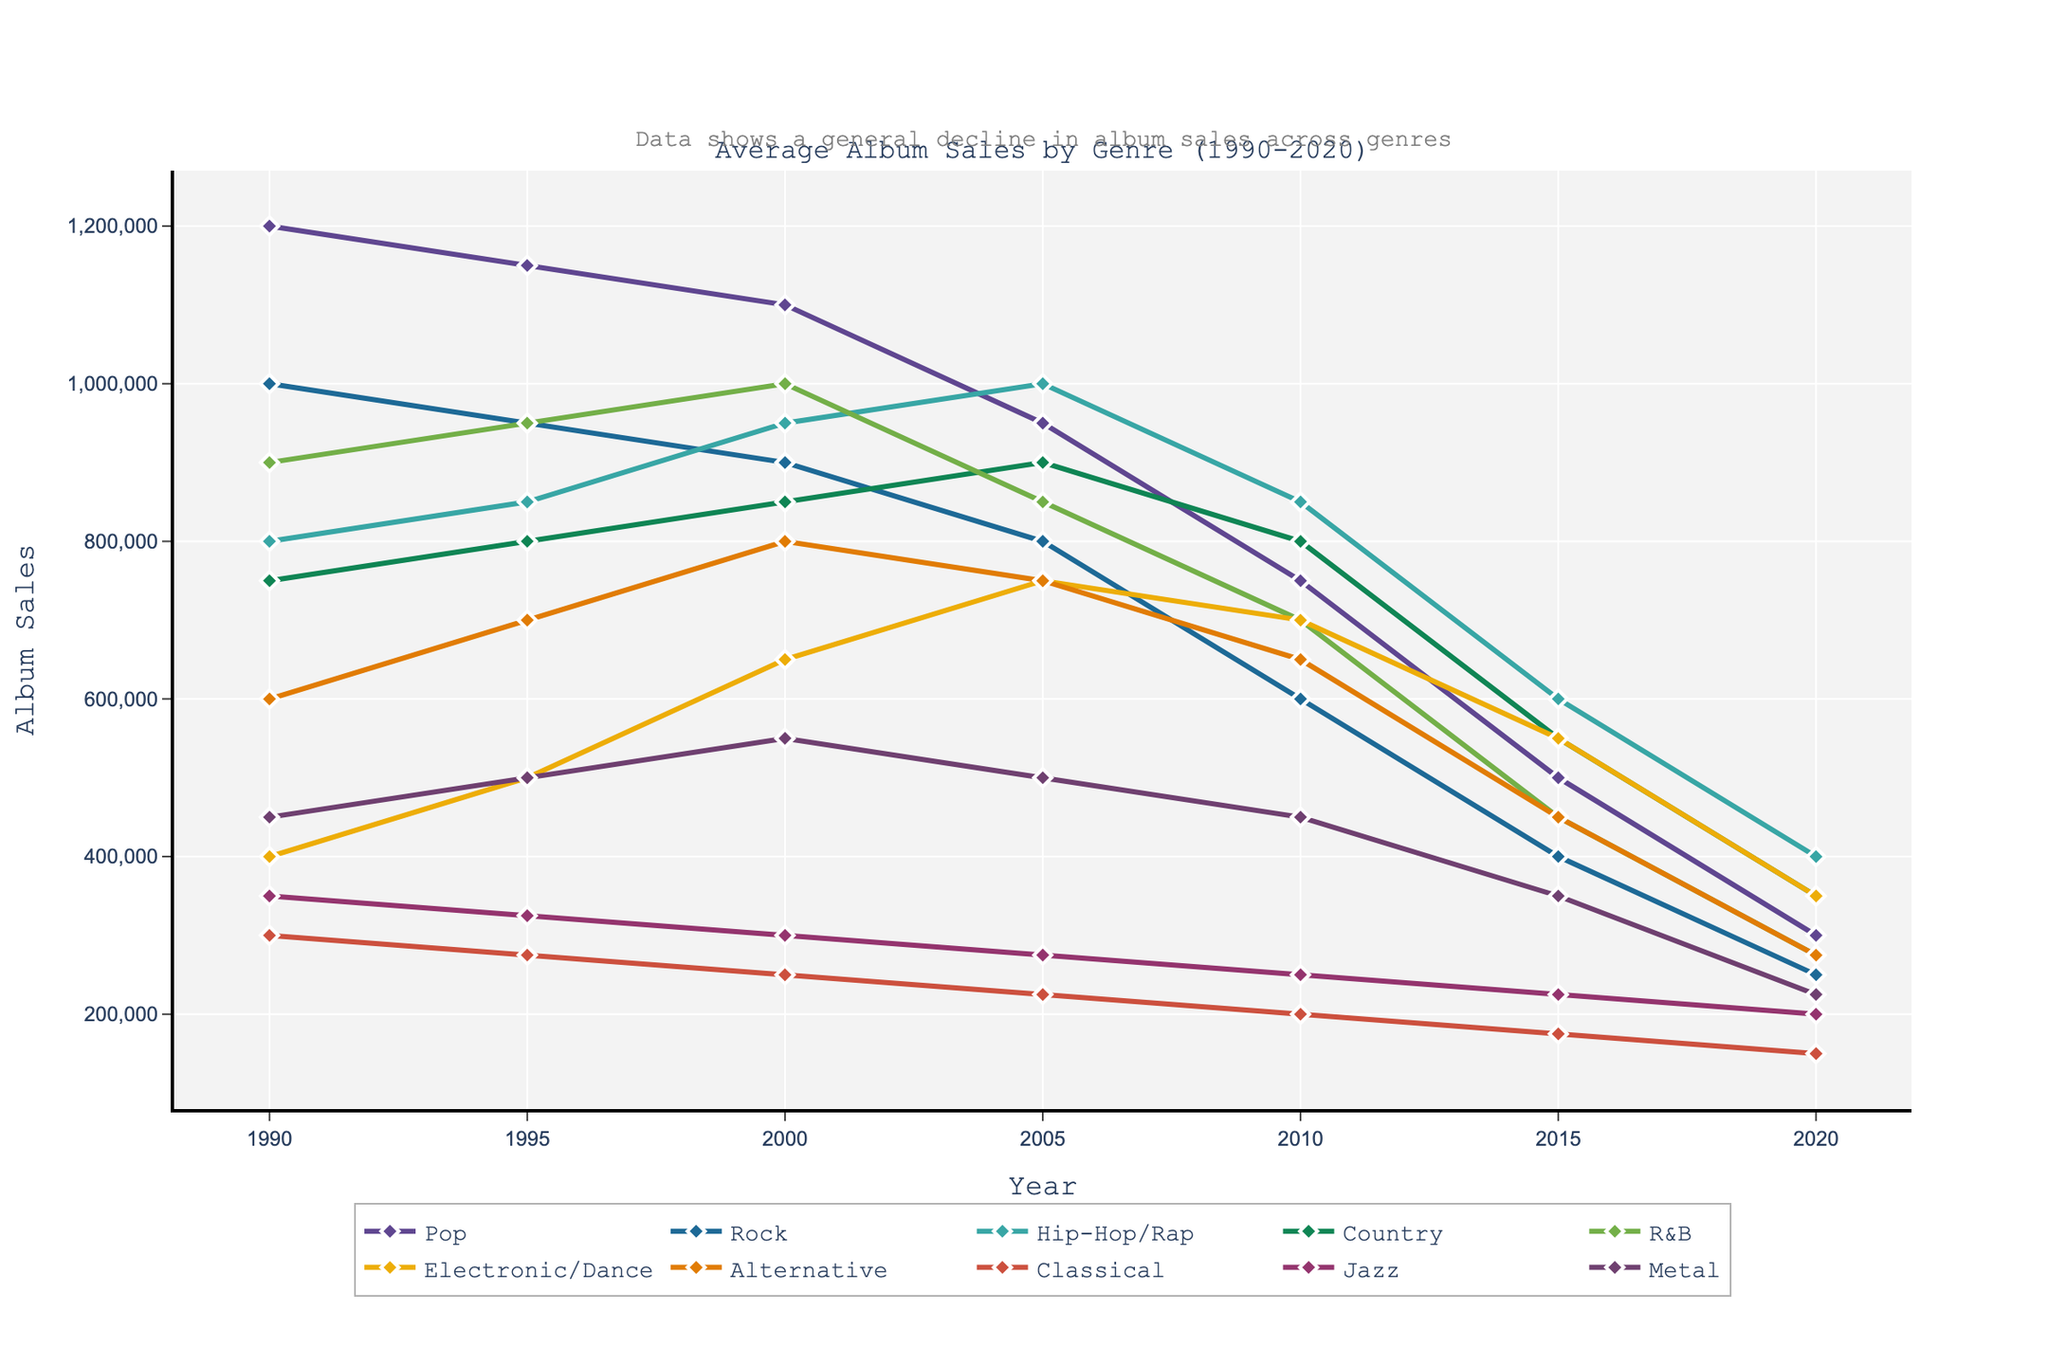What's the overall trend in album sales for most genres from 1990 to 2020? Most genres show a declining trend in album sales from 1990 to 2020. By examining the slopes of the lines for each genre, it is apparent that the lines generally slope downward over time.
Answer: Declining Which genre had the highest average album sales in 2000? By referring to the height of the lines at the year 2000 marker, the R&B genre had the highest average album sales in 2000 with 1,000,000 units sold.
Answer: R&B Which genres maintained their album sales relatively stable from 1990 to 2000? By comparing the slopes of the lines between 1990 to 2000, Electronic/Dance and Jazz show relatively stable sales where their lines do not have large dips or rises.
Answer: Electronic/Dance, Jazz Which genre had the steepest decline in album sales from 1990 to 2020? To determine the steepest decline, compare the difference between the starting and ending points of each line. Pop had the steepest decline, going from 1,200,000 units in 1990 to 300,000 units in 2020.
Answer: Pop How do the sales of Hip-Hop/Rap in 2010 compare to the sales of Rock in 2000? By looking at the Y-axis values at the respective years, Hip-Hop/Rap in 2010 had approximately 850,000 units sold, while Rock in 2000 had about 900,000 units sold.
Answer: Rock had higher sales in 2000 What’s the average album sales for the Pop genre between 1990 and 2020? Sum of sales values for Pop (1200000, 1150000, 1100000, 950000, 750000, 500000, 300000) and divide by 7. The calculation is (1200000 + 1150000 + 1100000 + 950000 + 750000 + 500000 + 300000) / 7
Answer: 785714 Which genre saw an increase in album sales between 1990 and 2005? By analyzing the lines from 1990 to 2005, Hip-Hop/Rap and Electronic/Dance show an increase over this period.
Answer: Hip-Hop/Rap, Electronic/Dance What was the range of album sales for the Classical genre in the given time period? The range of album sales values for Classical is found by subtracting the minimum value (150,000 in 2020) from the maximum value (300,000 in 1990).
Answer: 150,000 Compare the album sales of Country in 2005 with Alternative in 2015. Which one is higher? Referring to the Y-axis values, Country in 2005 had 900,000 units while Alternative in 2015 had 450,000 units. Therefore, Country had higher sales in 2005.
Answer: Country How did the album sales for Metal compare in 1990 and 2020? By looking at the line for Metal at 1990 and 2020, the album sales in 1990 were 450,000 and in 2020, they were 225,000. Therefore, sales in 1990 were higher.
Answer: Higher in 1990 